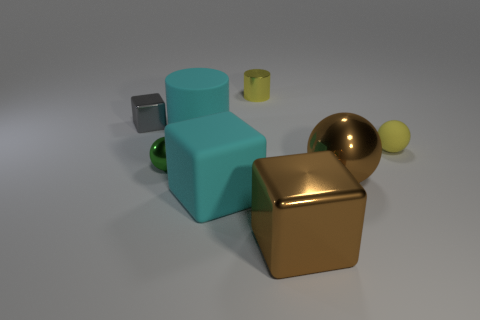There is another small thing that is the same shape as the green shiny object; what is its material?
Keep it short and to the point. Rubber. There is a yellow cylinder right of the tiny ball that is on the left side of the tiny yellow shiny thing; what size is it?
Offer a terse response. Small. What is the material of the ball that is on the left side of the large cyan rubber cube?
Your response must be concise. Metal. There is a cube that is made of the same material as the cyan cylinder; what is its size?
Keep it short and to the point. Large. What number of big objects have the same shape as the small gray thing?
Make the answer very short. 2. Is the shape of the small yellow matte object the same as the cyan thing that is behind the green shiny ball?
Give a very brief answer. No. There is a big thing that is the same color as the large matte block; what shape is it?
Provide a succinct answer. Cylinder. Are there any tiny cyan spheres made of the same material as the gray block?
Offer a very short reply. No. Is there anything else that is the same material as the big brown sphere?
Make the answer very short. Yes. What material is the sphere to the left of the large matte object that is to the right of the big matte cylinder?
Keep it short and to the point. Metal. 